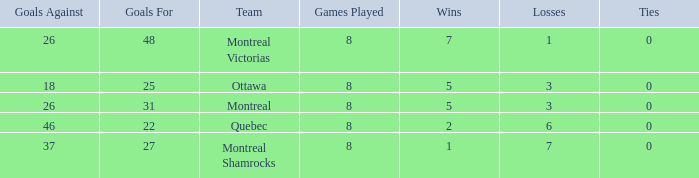How many losses did the team with 22 goals for andmore than 8 games played have? 0.0. 